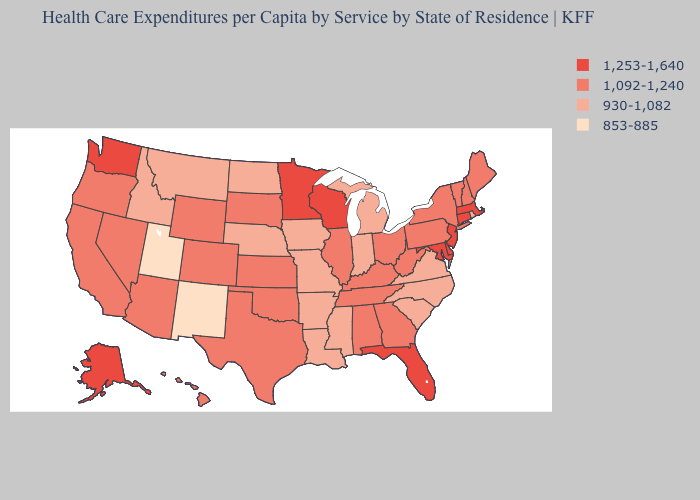Does Kansas have the same value as Pennsylvania?
Concise answer only. Yes. What is the value of Kentucky?
Quick response, please. 1,092-1,240. Name the states that have a value in the range 930-1,082?
Answer briefly. Arkansas, Idaho, Indiana, Iowa, Louisiana, Michigan, Mississippi, Missouri, Montana, Nebraska, North Carolina, North Dakota, Rhode Island, South Carolina, Virginia. What is the lowest value in the MidWest?
Concise answer only. 930-1,082. Does Montana have a higher value than Rhode Island?
Short answer required. No. What is the value of Wyoming?
Keep it brief. 1,092-1,240. Among the states that border Wyoming , does Colorado have the highest value?
Concise answer only. Yes. What is the value of Washington?
Write a very short answer. 1,253-1,640. Does Arkansas have the highest value in the USA?
Be succinct. No. What is the value of New York?
Short answer required. 1,092-1,240. What is the value of New Hampshire?
Answer briefly. 1,092-1,240. What is the lowest value in states that border New Hampshire?
Concise answer only. 1,092-1,240. Is the legend a continuous bar?
Write a very short answer. No. Which states have the lowest value in the South?
Concise answer only. Arkansas, Louisiana, Mississippi, North Carolina, South Carolina, Virginia. What is the value of Washington?
Keep it brief. 1,253-1,640. 